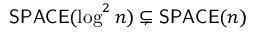Convert formula to latex. <formula><loc_0><loc_0><loc_500><loc_500>{ S P A C E } ( \log ^ { 2 } n ) \subsetneq { S P A C E } ( n )</formula> 